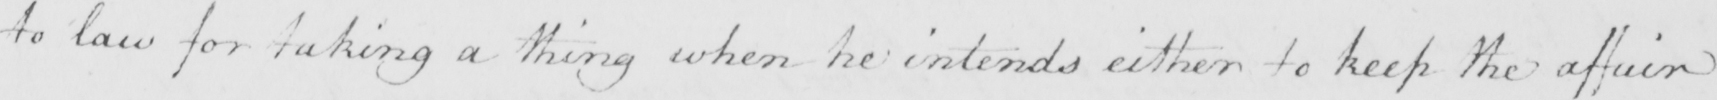Can you read and transcribe this handwriting? to law for taking a thing when he intends either to keep the affair 